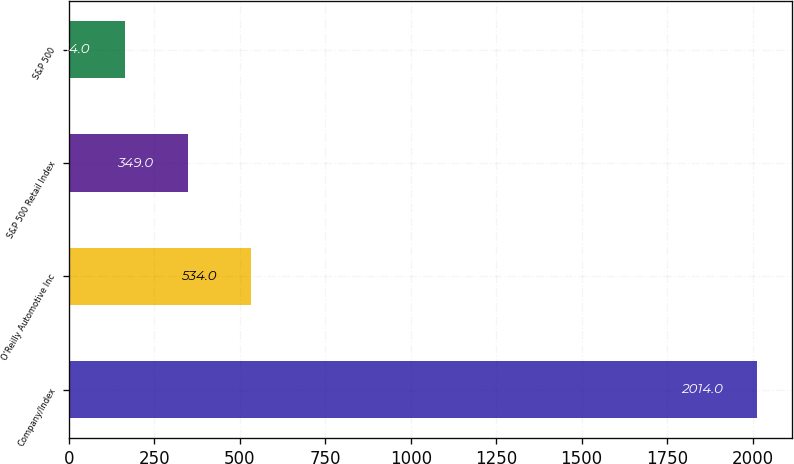Convert chart to OTSL. <chart><loc_0><loc_0><loc_500><loc_500><bar_chart><fcel>Company/Index<fcel>O'Reilly Automotive Inc<fcel>S&P 500 Retail Index<fcel>S&P 500<nl><fcel>2014<fcel>534<fcel>349<fcel>164<nl></chart> 